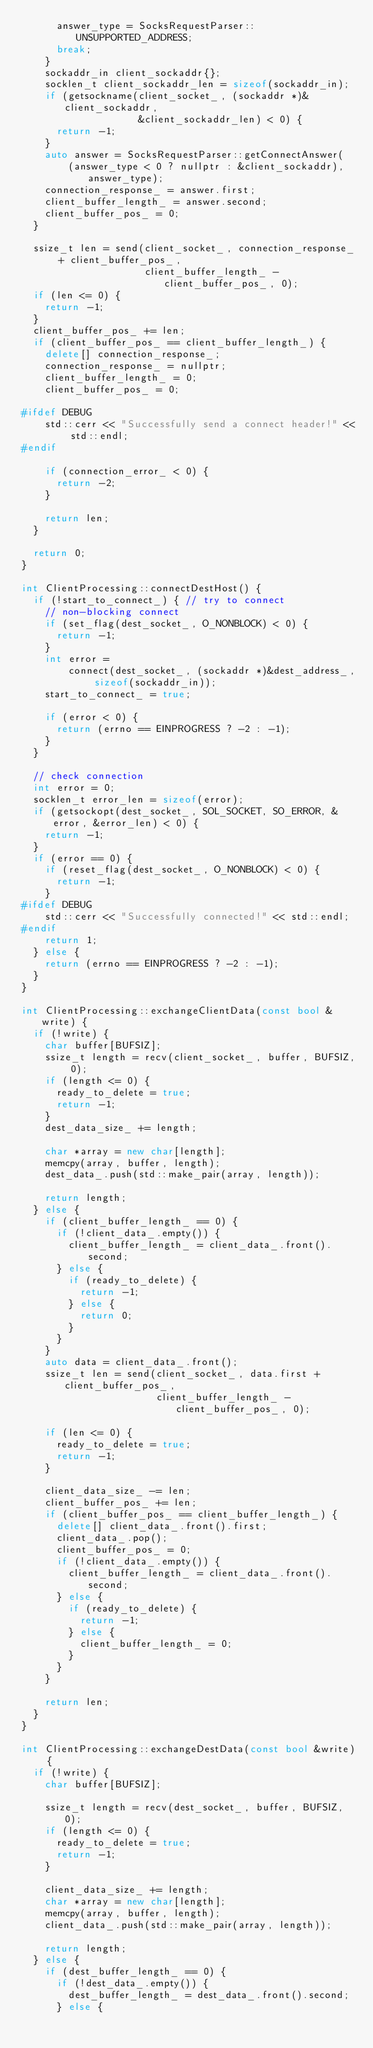Convert code to text. <code><loc_0><loc_0><loc_500><loc_500><_C++_>      answer_type = SocksRequestParser::UNSUPPORTED_ADDRESS;
      break;
    }
    sockaddr_in client_sockaddr{};
    socklen_t client_sockaddr_len = sizeof(sockaddr_in);
    if (getsockname(client_socket_, (sockaddr *)&client_sockaddr,
                    &client_sockaddr_len) < 0) {
      return -1;
    }
    auto answer = SocksRequestParser::getConnectAnswer(
        (answer_type < 0 ? nullptr : &client_sockaddr), answer_type);
    connection_response_ = answer.first;
    client_buffer_length_ = answer.second;
    client_buffer_pos_ = 0;
  }

  ssize_t len = send(client_socket_, connection_response_ + client_buffer_pos_,
                     client_buffer_length_ - client_buffer_pos_, 0);
  if (len <= 0) {
    return -1;
  }
  client_buffer_pos_ += len;
  if (client_buffer_pos_ == client_buffer_length_) {
    delete[] connection_response_;
    connection_response_ = nullptr;
    client_buffer_length_ = 0;
    client_buffer_pos_ = 0;

#ifdef DEBUG
    std::cerr << "Successfully send a connect header!" << std::endl;
#endif

    if (connection_error_ < 0) {
      return -2;
    }

    return len;
  }

  return 0;
}

int ClientProcessing::connectDestHost() {
  if (!start_to_connect_) { // try to connect
    // non-blocking connect
    if (set_flag(dest_socket_, O_NONBLOCK) < 0) {
      return -1;
    }
    int error =
        connect(dest_socket_, (sockaddr *)&dest_address_, sizeof(sockaddr_in));
    start_to_connect_ = true;

    if (error < 0) {
      return (errno == EINPROGRESS ? -2 : -1);
    }
  }

  // check connection
  int error = 0;
  socklen_t error_len = sizeof(error);
  if (getsockopt(dest_socket_, SOL_SOCKET, SO_ERROR, &error, &error_len) < 0) {
    return -1;
  }
  if (error == 0) {
    if (reset_flag(dest_socket_, O_NONBLOCK) < 0) {
      return -1;
    }
#ifdef DEBUG
    std::cerr << "Successfully connected!" << std::endl;
#endif
    return 1;
  } else {
    return (errno == EINPROGRESS ? -2 : -1);
  }
}

int ClientProcessing::exchangeClientData(const bool &write) {
  if (!write) {
    char buffer[BUFSIZ];
    ssize_t length = recv(client_socket_, buffer, BUFSIZ, 0);
    if (length <= 0) {
      ready_to_delete = true;
      return -1;
    }
    dest_data_size_ += length;

    char *array = new char[length];
    memcpy(array, buffer, length);
    dest_data_.push(std::make_pair(array, length));

    return length;
  } else {
    if (client_buffer_length_ == 0) {
      if (!client_data_.empty()) {
        client_buffer_length_ = client_data_.front().second;
      } else {
        if (ready_to_delete) {
          return -1;
        } else {
          return 0;
        }
      }
    }
    auto data = client_data_.front();
    ssize_t len = send(client_socket_, data.first + client_buffer_pos_,
                       client_buffer_length_ - client_buffer_pos_, 0);

    if (len <= 0) {
      ready_to_delete = true;
      return -1;
    }

    client_data_size_ -= len;
    client_buffer_pos_ += len;
    if (client_buffer_pos_ == client_buffer_length_) {
      delete[] client_data_.front().first;
      client_data_.pop();
      client_buffer_pos_ = 0;
      if (!client_data_.empty()) {
        client_buffer_length_ = client_data_.front().second;
      } else {
        if (ready_to_delete) {
          return -1;
        } else {
          client_buffer_length_ = 0;
        }
      }
    }

    return len;
  }
}

int ClientProcessing::exchangeDestData(const bool &write) {
  if (!write) {
    char buffer[BUFSIZ];

    ssize_t length = recv(dest_socket_, buffer, BUFSIZ, 0);
    if (length <= 0) {
      ready_to_delete = true;
      return -1;
    }

    client_data_size_ += length;
    char *array = new char[length];
    memcpy(array, buffer, length);
    client_data_.push(std::make_pair(array, length));

    return length;
  } else {
    if (dest_buffer_length_ == 0) {
      if (!dest_data_.empty()) {
        dest_buffer_length_ = dest_data_.front().second;
      } else {</code> 